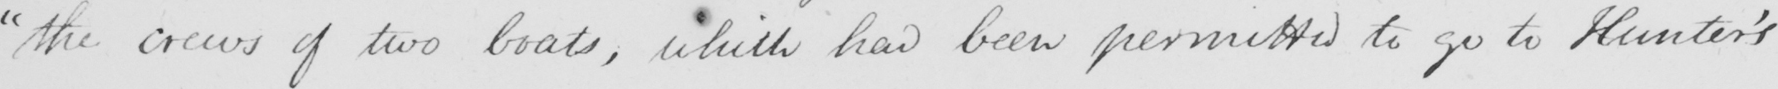What does this handwritten line say? " the crews of two boats , which had been permitted to go to Hunter ' s 